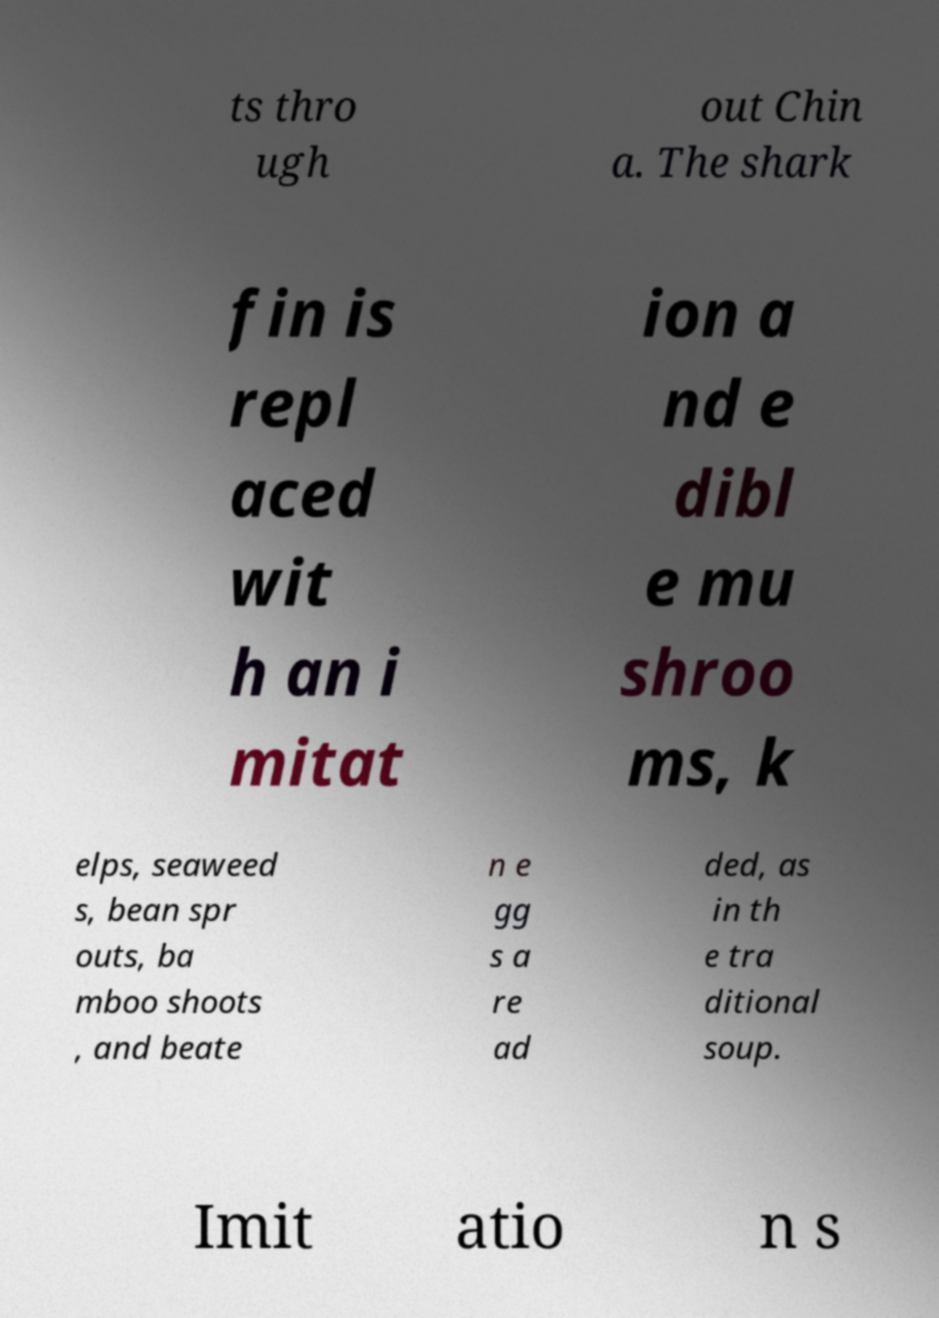I need the written content from this picture converted into text. Can you do that? ts thro ugh out Chin a. The shark fin is repl aced wit h an i mitat ion a nd e dibl e mu shroo ms, k elps, seaweed s, bean spr outs, ba mboo shoots , and beate n e gg s a re ad ded, as in th e tra ditional soup. Imit atio n s 